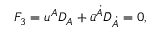Convert formula to latex. <formula><loc_0><loc_0><loc_500><loc_500>F _ { 3 } = { u } ^ { A } D _ { A } + { \bar { u } } ^ { \dot { A } } { \bar { D } } _ { \dot { A } } = 0 ,</formula> 